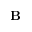<formula> <loc_0><loc_0><loc_500><loc_500>{ B }</formula> 